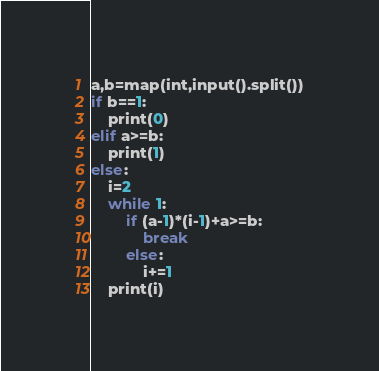Convert code to text. <code><loc_0><loc_0><loc_500><loc_500><_Python_>a,b=map(int,input().split())
if b==1:
    print(0)
elif a>=b:
    print(1)
else:
    i=2
    while 1:
        if (a-1)*(i-1)+a>=b:
            break
        else:
            i+=1
    print(i)
</code> 